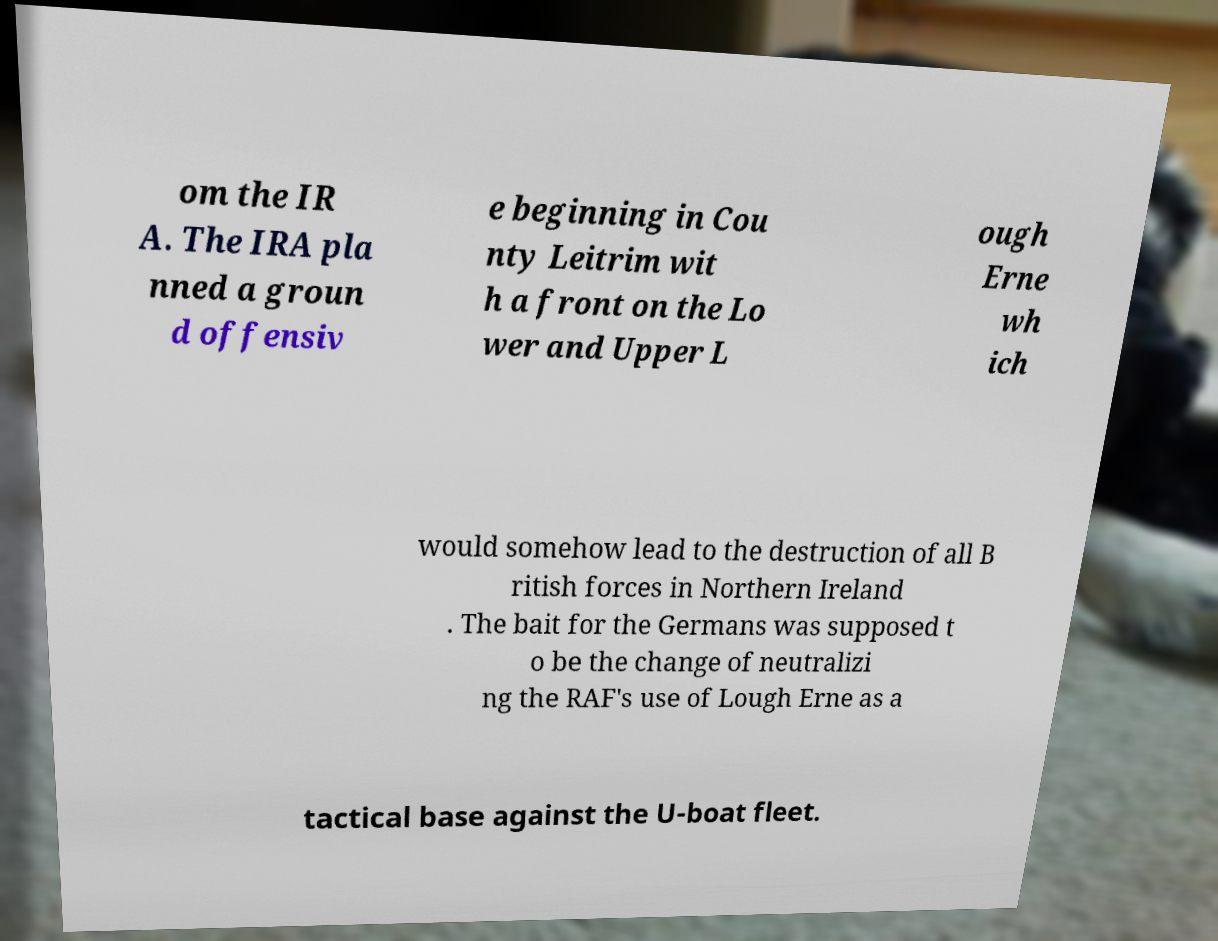Could you extract and type out the text from this image? om the IR A. The IRA pla nned a groun d offensiv e beginning in Cou nty Leitrim wit h a front on the Lo wer and Upper L ough Erne wh ich would somehow lead to the destruction of all B ritish forces in Northern Ireland . The bait for the Germans was supposed t o be the change of neutralizi ng the RAF's use of Lough Erne as a tactical base against the U-boat fleet. 